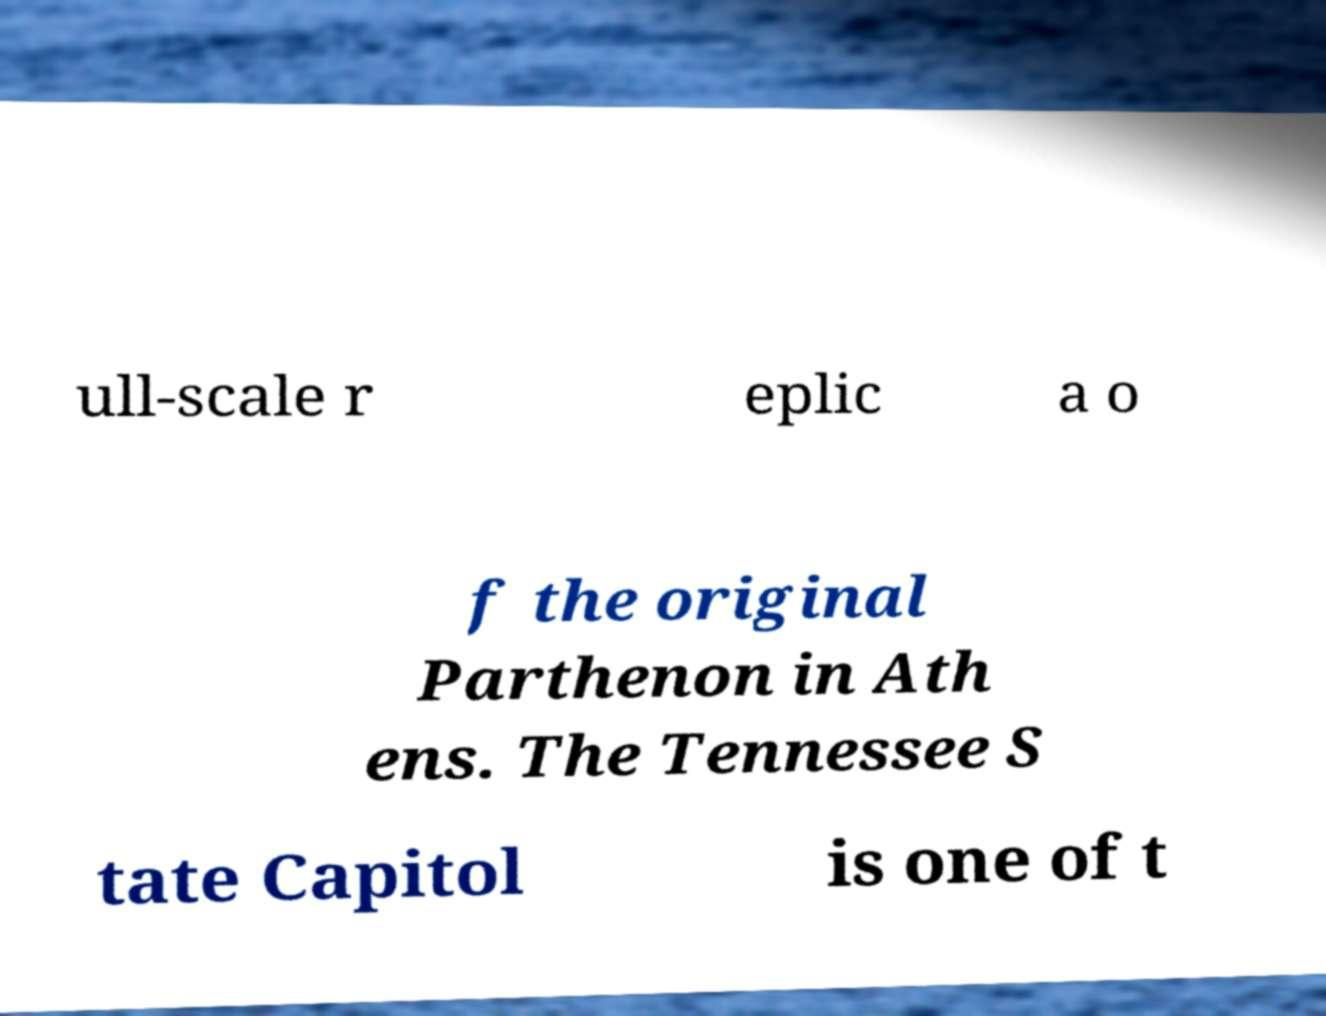I need the written content from this picture converted into text. Can you do that? ull-scale r eplic a o f the original Parthenon in Ath ens. The Tennessee S tate Capitol is one of t 